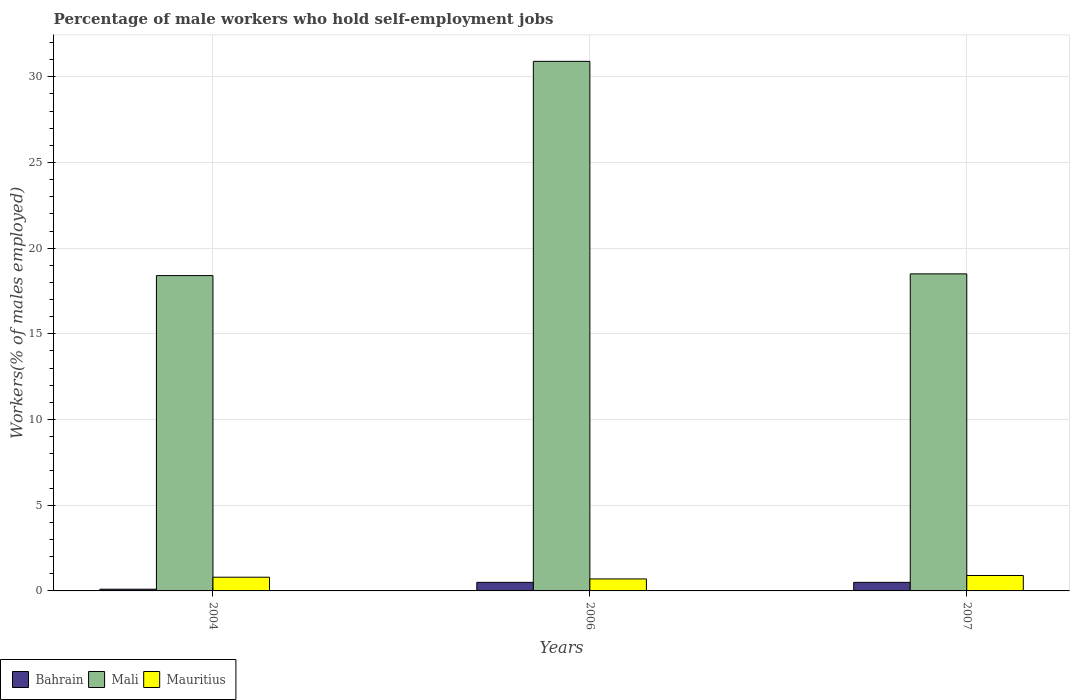How many different coloured bars are there?
Your answer should be very brief. 3. Are the number of bars per tick equal to the number of legend labels?
Provide a succinct answer. Yes. How many bars are there on the 1st tick from the right?
Give a very brief answer. 3. In how many cases, is the number of bars for a given year not equal to the number of legend labels?
Your answer should be very brief. 0. What is the percentage of self-employed male workers in Mauritius in 2007?
Keep it short and to the point. 0.9. Across all years, what is the maximum percentage of self-employed male workers in Mauritius?
Keep it short and to the point. 0.9. Across all years, what is the minimum percentage of self-employed male workers in Bahrain?
Give a very brief answer. 0.1. In which year was the percentage of self-employed male workers in Bahrain minimum?
Provide a short and direct response. 2004. What is the total percentage of self-employed male workers in Mauritius in the graph?
Make the answer very short. 2.4. What is the difference between the percentage of self-employed male workers in Mauritius in 2004 and that in 2007?
Give a very brief answer. -0.1. What is the difference between the percentage of self-employed male workers in Mali in 2007 and the percentage of self-employed male workers in Mauritius in 2006?
Give a very brief answer. 17.8. What is the average percentage of self-employed male workers in Bahrain per year?
Your response must be concise. 0.37. In the year 2004, what is the difference between the percentage of self-employed male workers in Mauritius and percentage of self-employed male workers in Bahrain?
Your answer should be very brief. 0.7. What is the ratio of the percentage of self-employed male workers in Mali in 2004 to that in 2006?
Offer a terse response. 0.6. Is the difference between the percentage of self-employed male workers in Mauritius in 2004 and 2006 greater than the difference between the percentage of self-employed male workers in Bahrain in 2004 and 2006?
Your answer should be very brief. Yes. What is the difference between the highest and the second highest percentage of self-employed male workers in Mauritius?
Keep it short and to the point. 0.1. What is the difference between the highest and the lowest percentage of self-employed male workers in Mauritius?
Keep it short and to the point. 0.2. What does the 2nd bar from the left in 2004 represents?
Provide a succinct answer. Mali. What does the 3rd bar from the right in 2004 represents?
Your answer should be compact. Bahrain. Is it the case that in every year, the sum of the percentage of self-employed male workers in Mali and percentage of self-employed male workers in Bahrain is greater than the percentage of self-employed male workers in Mauritius?
Offer a very short reply. Yes. How many bars are there?
Provide a short and direct response. 9. Are all the bars in the graph horizontal?
Ensure brevity in your answer.  No. What is the difference between two consecutive major ticks on the Y-axis?
Your answer should be compact. 5. Are the values on the major ticks of Y-axis written in scientific E-notation?
Give a very brief answer. No. Where does the legend appear in the graph?
Ensure brevity in your answer.  Bottom left. How many legend labels are there?
Offer a terse response. 3. What is the title of the graph?
Your response must be concise. Percentage of male workers who hold self-employment jobs. Does "Palau" appear as one of the legend labels in the graph?
Offer a very short reply. No. What is the label or title of the Y-axis?
Keep it short and to the point. Workers(% of males employed). What is the Workers(% of males employed) in Bahrain in 2004?
Provide a short and direct response. 0.1. What is the Workers(% of males employed) in Mali in 2004?
Give a very brief answer. 18.4. What is the Workers(% of males employed) of Mauritius in 2004?
Give a very brief answer. 0.8. What is the Workers(% of males employed) in Bahrain in 2006?
Your answer should be compact. 0.5. What is the Workers(% of males employed) of Mali in 2006?
Provide a short and direct response. 30.9. What is the Workers(% of males employed) of Mauritius in 2006?
Provide a succinct answer. 0.7. What is the Workers(% of males employed) of Bahrain in 2007?
Your response must be concise. 0.5. What is the Workers(% of males employed) in Mali in 2007?
Your response must be concise. 18.5. What is the Workers(% of males employed) of Mauritius in 2007?
Offer a terse response. 0.9. Across all years, what is the maximum Workers(% of males employed) in Bahrain?
Offer a terse response. 0.5. Across all years, what is the maximum Workers(% of males employed) of Mali?
Ensure brevity in your answer.  30.9. Across all years, what is the maximum Workers(% of males employed) in Mauritius?
Give a very brief answer. 0.9. Across all years, what is the minimum Workers(% of males employed) in Bahrain?
Make the answer very short. 0.1. Across all years, what is the minimum Workers(% of males employed) in Mali?
Your answer should be compact. 18.4. Across all years, what is the minimum Workers(% of males employed) of Mauritius?
Your answer should be compact. 0.7. What is the total Workers(% of males employed) in Mali in the graph?
Your answer should be compact. 67.8. What is the difference between the Workers(% of males employed) in Bahrain in 2004 and that in 2006?
Your response must be concise. -0.4. What is the difference between the Workers(% of males employed) of Mali in 2004 and that in 2006?
Offer a terse response. -12.5. What is the difference between the Workers(% of males employed) in Mali in 2004 and that in 2007?
Your answer should be compact. -0.1. What is the difference between the Workers(% of males employed) in Bahrain in 2006 and that in 2007?
Ensure brevity in your answer.  0. What is the difference between the Workers(% of males employed) of Mali in 2006 and that in 2007?
Give a very brief answer. 12.4. What is the difference between the Workers(% of males employed) of Bahrain in 2004 and the Workers(% of males employed) of Mali in 2006?
Ensure brevity in your answer.  -30.8. What is the difference between the Workers(% of males employed) of Mali in 2004 and the Workers(% of males employed) of Mauritius in 2006?
Offer a very short reply. 17.7. What is the difference between the Workers(% of males employed) in Bahrain in 2004 and the Workers(% of males employed) in Mali in 2007?
Offer a very short reply. -18.4. What is the difference between the Workers(% of males employed) in Bahrain in 2004 and the Workers(% of males employed) in Mauritius in 2007?
Offer a very short reply. -0.8. What is the difference between the Workers(% of males employed) of Mali in 2006 and the Workers(% of males employed) of Mauritius in 2007?
Provide a succinct answer. 30. What is the average Workers(% of males employed) in Bahrain per year?
Make the answer very short. 0.37. What is the average Workers(% of males employed) of Mali per year?
Your answer should be compact. 22.6. What is the average Workers(% of males employed) of Mauritius per year?
Your answer should be very brief. 0.8. In the year 2004, what is the difference between the Workers(% of males employed) in Bahrain and Workers(% of males employed) in Mali?
Offer a very short reply. -18.3. In the year 2004, what is the difference between the Workers(% of males employed) in Mali and Workers(% of males employed) in Mauritius?
Offer a terse response. 17.6. In the year 2006, what is the difference between the Workers(% of males employed) of Bahrain and Workers(% of males employed) of Mali?
Keep it short and to the point. -30.4. In the year 2006, what is the difference between the Workers(% of males employed) in Mali and Workers(% of males employed) in Mauritius?
Keep it short and to the point. 30.2. In the year 2007, what is the difference between the Workers(% of males employed) in Bahrain and Workers(% of males employed) in Mali?
Provide a short and direct response. -18. What is the ratio of the Workers(% of males employed) in Bahrain in 2004 to that in 2006?
Your answer should be very brief. 0.2. What is the ratio of the Workers(% of males employed) of Mali in 2004 to that in 2006?
Give a very brief answer. 0.6. What is the ratio of the Workers(% of males employed) in Mauritius in 2004 to that in 2006?
Offer a terse response. 1.14. What is the ratio of the Workers(% of males employed) of Mali in 2004 to that in 2007?
Offer a very short reply. 0.99. What is the ratio of the Workers(% of males employed) in Mauritius in 2004 to that in 2007?
Ensure brevity in your answer.  0.89. What is the ratio of the Workers(% of males employed) in Mali in 2006 to that in 2007?
Keep it short and to the point. 1.67. What is the ratio of the Workers(% of males employed) of Mauritius in 2006 to that in 2007?
Keep it short and to the point. 0.78. What is the difference between the highest and the second highest Workers(% of males employed) of Bahrain?
Your answer should be compact. 0. What is the difference between the highest and the second highest Workers(% of males employed) in Mali?
Offer a very short reply. 12.4. What is the difference between the highest and the second highest Workers(% of males employed) of Mauritius?
Make the answer very short. 0.1. What is the difference between the highest and the lowest Workers(% of males employed) of Mali?
Your answer should be compact. 12.5. 